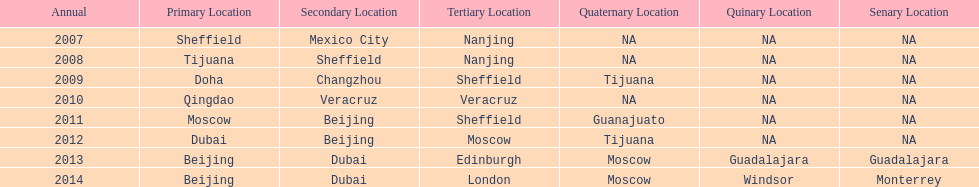Which year is previous to 2011 2010. 